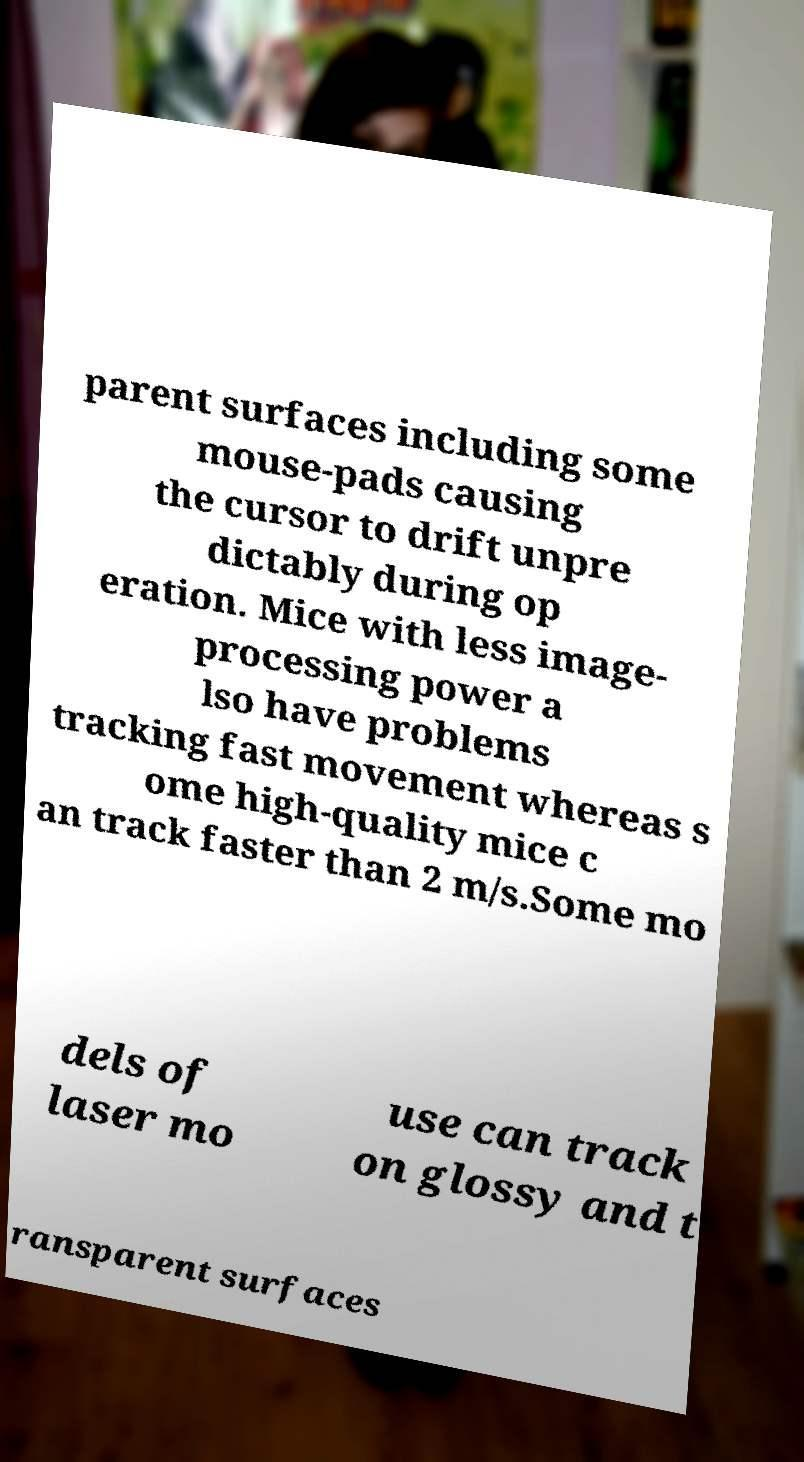Please identify and transcribe the text found in this image. parent surfaces including some mouse-pads causing the cursor to drift unpre dictably during op eration. Mice with less image- processing power a lso have problems tracking fast movement whereas s ome high-quality mice c an track faster than 2 m/s.Some mo dels of laser mo use can track on glossy and t ransparent surfaces 